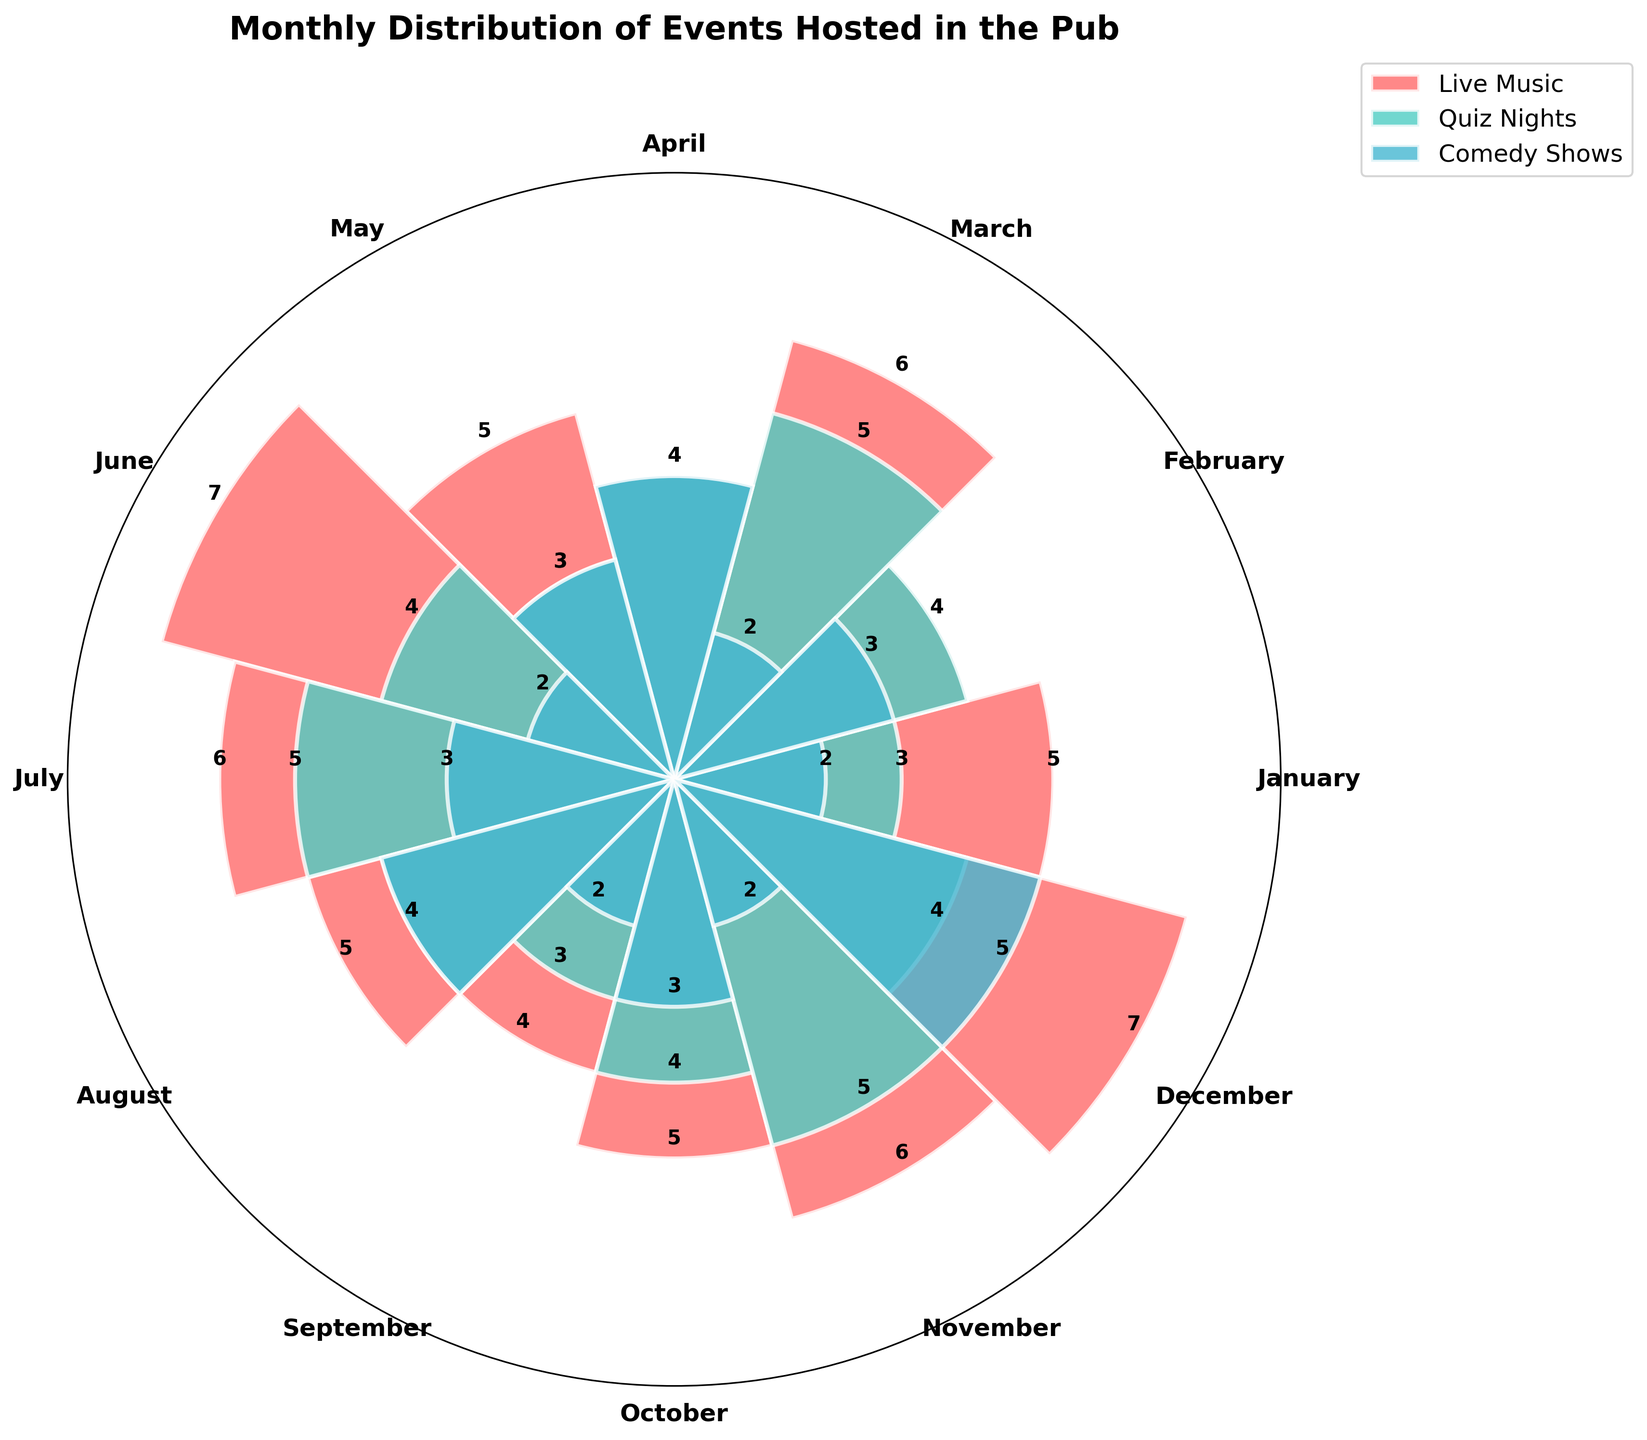What is the title of the rose chart? The title is displayed at the top of the chart, which reads "Monthly Distribution of Events Hosted in the Pub".
Answer: Monthly Distribution of Events Hosted in the Pub How many months are displayed in the chart? The chart has a circular layout with 12 segments, each labeled with a different month.
Answer: 12 What color represents 'Quiz Nights'? The color scheme shows 'Quiz Nights' in a different color from the other categories, which appears to be a shade of cyan/teal.
Answer: cyan/teal Which month has the highest number of 'Live Music' events? The height of the bars for 'Live Music' events is the tallest in the month of December.
Answer: December How many 'Comedy Shows' were hosted in April? The height of the bar representing 'Comedy Shows' in April reaches up to 4 events.
Answer: 4 What is the total number of 'Live Music' events hosted throughout the year? The values for 'Live Music' events are 5, 4, 6, 4, 5, 7, 6, 5, 4, 5, 6, 7. Adding them up gives a total of 64 events.
Answer: 64 In which month are the 'Quiz Nights' and 'Comedy Shows' equal in number? Observing the heights of bars across both categories, February shows 4 events each for both 'Quiz Nights' and 'Comedy Shows'.
Answer: February How does the number of 'Live Music' events in June compare to November? Both months have the same height bars for 'Live Music', which are at 7 events each.
Answer: Same/Equal What’s the combined total events in December for all categories? Summing up the events hosted in December: 'Live Music' (7), 'Quiz Nights' (4), and 'Comedy Shows' (5), gives 16 events in total.
Answer: 16 Which category has the least fluctuation in numbers across the months? By examining the heights of bars for all categories, 'Quiz Nights' shows the least variation, with its values mainly oscillating between 3 and 5.
Answer: Quiz Nights 